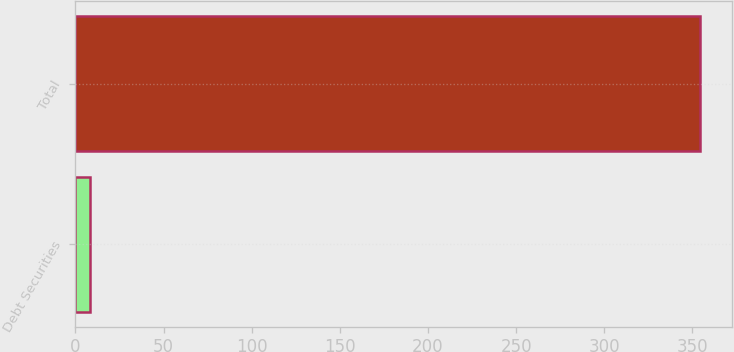Convert chart to OTSL. <chart><loc_0><loc_0><loc_500><loc_500><bar_chart><fcel>Debt Securities<fcel>Total<nl><fcel>8<fcel>354.6<nl></chart> 